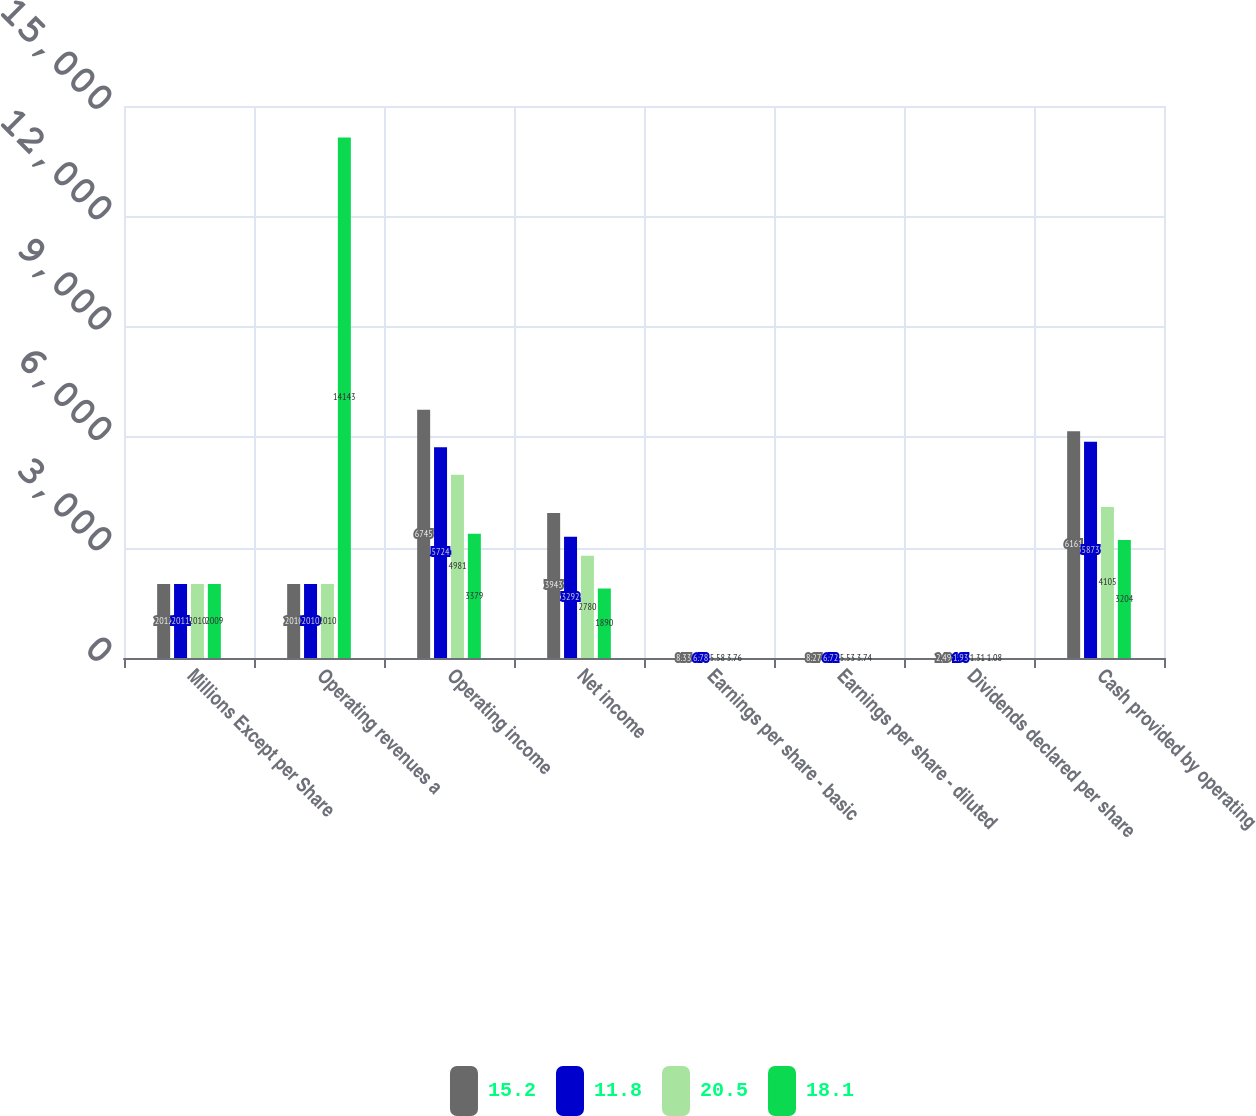<chart> <loc_0><loc_0><loc_500><loc_500><stacked_bar_chart><ecel><fcel>Millions Except per Share<fcel>Operating revenues a<fcel>Operating income<fcel>Net income<fcel>Earnings per share - basic<fcel>Earnings per share - diluted<fcel>Dividends declared per share<fcel>Cash provided by operating<nl><fcel>15.2<fcel>2012<fcel>2010<fcel>6745<fcel>3943<fcel>8.33<fcel>8.27<fcel>2.49<fcel>6161<nl><fcel>11.8<fcel>2011<fcel>2010<fcel>5724<fcel>3292<fcel>6.78<fcel>6.72<fcel>1.93<fcel>5873<nl><fcel>20.5<fcel>2010<fcel>2010<fcel>4981<fcel>2780<fcel>5.58<fcel>5.53<fcel>1.31<fcel>4105<nl><fcel>18.1<fcel>2009<fcel>14143<fcel>3379<fcel>1890<fcel>3.76<fcel>3.74<fcel>1.08<fcel>3204<nl></chart> 